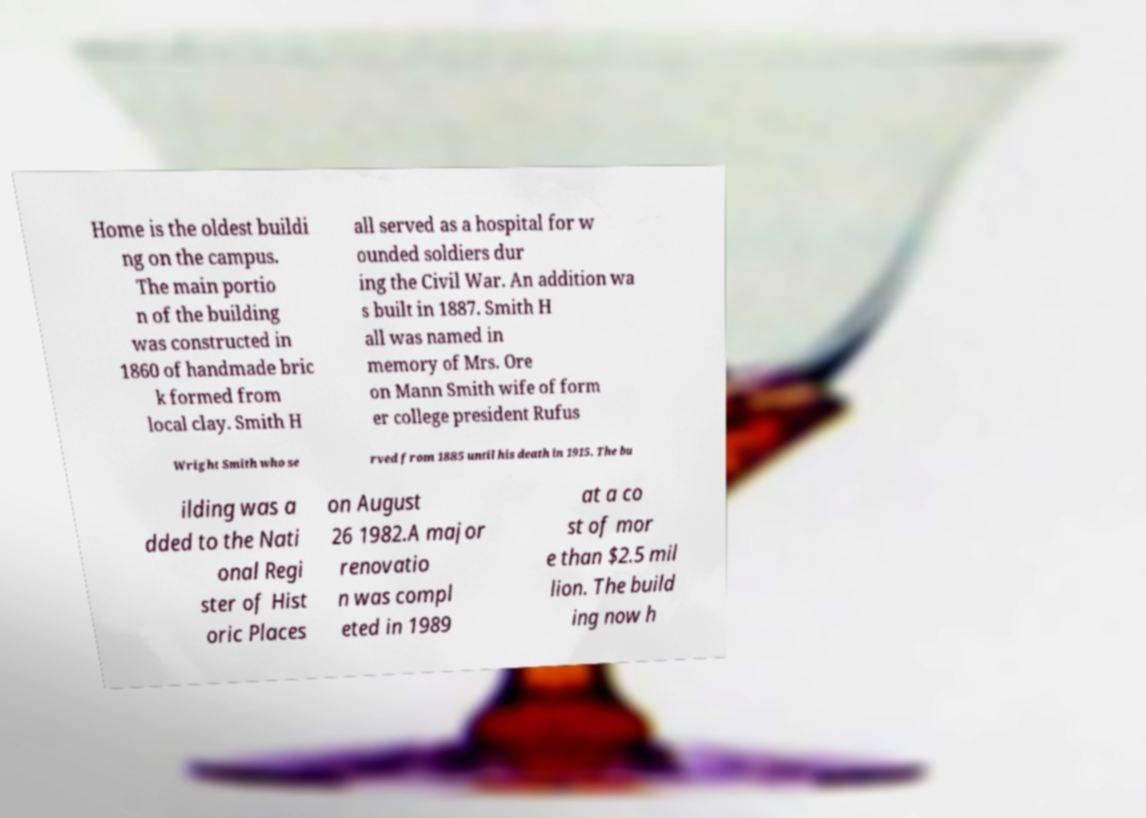Can you read and provide the text displayed in the image?This photo seems to have some interesting text. Can you extract and type it out for me? Home is the oldest buildi ng on the campus. The main portio n of the building was constructed in 1860 of handmade bric k formed from local clay. Smith H all served as a hospital for w ounded soldiers dur ing the Civil War. An addition wa s built in 1887. Smith H all was named in memory of Mrs. Ore on Mann Smith wife of form er college president Rufus Wright Smith who se rved from 1885 until his death in 1915. The bu ilding was a dded to the Nati onal Regi ster of Hist oric Places on August 26 1982.A major renovatio n was compl eted in 1989 at a co st of mor e than $2.5 mil lion. The build ing now h 